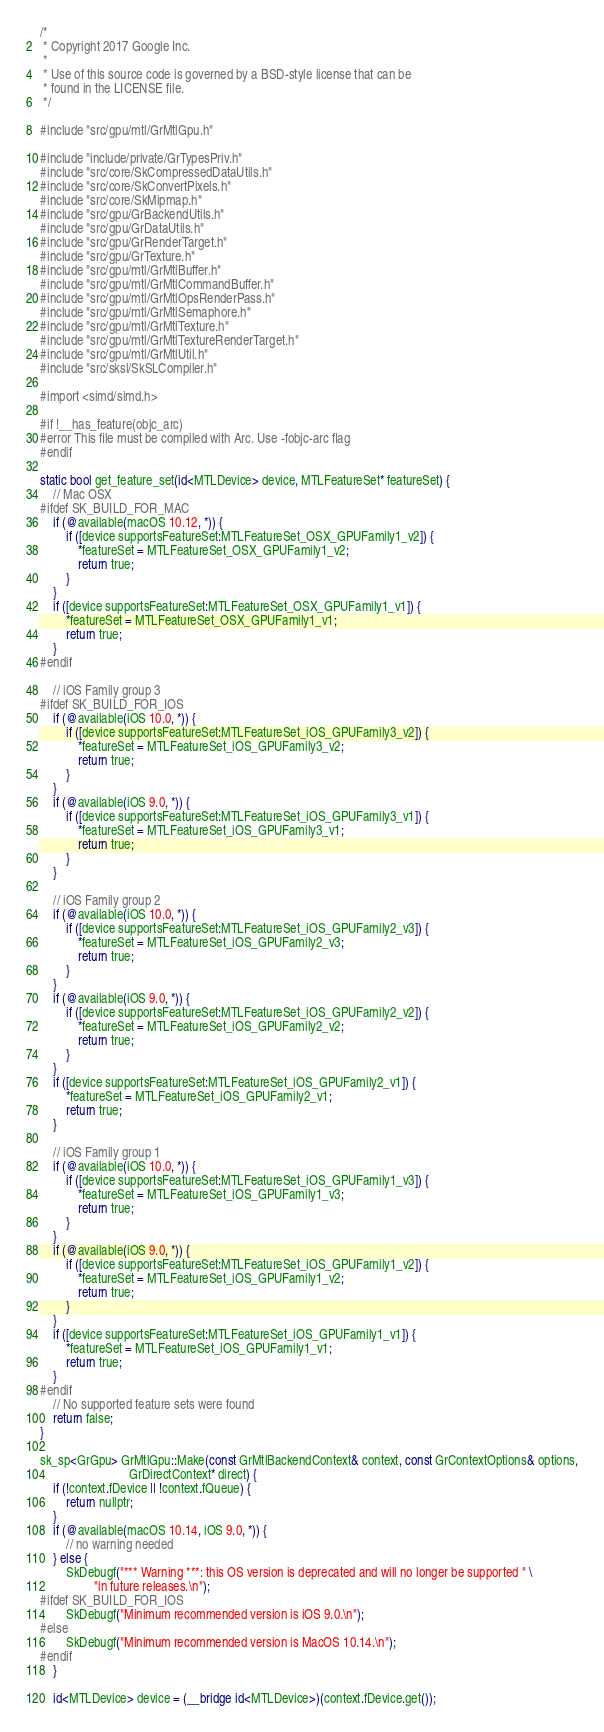<code> <loc_0><loc_0><loc_500><loc_500><_ObjectiveC_>/*
 * Copyright 2017 Google Inc.
 *
 * Use of this source code is governed by a BSD-style license that can be
 * found in the LICENSE file.
 */

#include "src/gpu/mtl/GrMtlGpu.h"

#include "include/private/GrTypesPriv.h"
#include "src/core/SkCompressedDataUtils.h"
#include "src/core/SkConvertPixels.h"
#include "src/core/SkMipmap.h"
#include "src/gpu/GrBackendUtils.h"
#include "src/gpu/GrDataUtils.h"
#include "src/gpu/GrRenderTarget.h"
#include "src/gpu/GrTexture.h"
#include "src/gpu/mtl/GrMtlBuffer.h"
#include "src/gpu/mtl/GrMtlCommandBuffer.h"
#include "src/gpu/mtl/GrMtlOpsRenderPass.h"
#include "src/gpu/mtl/GrMtlSemaphore.h"
#include "src/gpu/mtl/GrMtlTexture.h"
#include "src/gpu/mtl/GrMtlTextureRenderTarget.h"
#include "src/gpu/mtl/GrMtlUtil.h"
#include "src/sksl/SkSLCompiler.h"

#import <simd/simd.h>

#if !__has_feature(objc_arc)
#error This file must be compiled with Arc. Use -fobjc-arc flag
#endif

static bool get_feature_set(id<MTLDevice> device, MTLFeatureSet* featureSet) {
    // Mac OSX
#ifdef SK_BUILD_FOR_MAC
    if (@available(macOS 10.12, *)) {
        if ([device supportsFeatureSet:MTLFeatureSet_OSX_GPUFamily1_v2]) {
            *featureSet = MTLFeatureSet_OSX_GPUFamily1_v2;
            return true;
        }
    }
    if ([device supportsFeatureSet:MTLFeatureSet_OSX_GPUFamily1_v1]) {
        *featureSet = MTLFeatureSet_OSX_GPUFamily1_v1;
        return true;
    }
#endif

    // iOS Family group 3
#ifdef SK_BUILD_FOR_IOS
    if (@available(iOS 10.0, *)) {
        if ([device supportsFeatureSet:MTLFeatureSet_iOS_GPUFamily3_v2]) {
            *featureSet = MTLFeatureSet_iOS_GPUFamily3_v2;
            return true;
        }
    }
    if (@available(iOS 9.0, *)) {
        if ([device supportsFeatureSet:MTLFeatureSet_iOS_GPUFamily3_v1]) {
            *featureSet = MTLFeatureSet_iOS_GPUFamily3_v1;
            return true;
        }
    }

    // iOS Family group 2
    if (@available(iOS 10.0, *)) {
        if ([device supportsFeatureSet:MTLFeatureSet_iOS_GPUFamily2_v3]) {
            *featureSet = MTLFeatureSet_iOS_GPUFamily2_v3;
            return true;
        }
    }
    if (@available(iOS 9.0, *)) {
        if ([device supportsFeatureSet:MTLFeatureSet_iOS_GPUFamily2_v2]) {
            *featureSet = MTLFeatureSet_iOS_GPUFamily2_v2;
            return true;
        }
    }
    if ([device supportsFeatureSet:MTLFeatureSet_iOS_GPUFamily2_v1]) {
        *featureSet = MTLFeatureSet_iOS_GPUFamily2_v1;
        return true;
    }

    // iOS Family group 1
    if (@available(iOS 10.0, *)) {
        if ([device supportsFeatureSet:MTLFeatureSet_iOS_GPUFamily1_v3]) {
            *featureSet = MTLFeatureSet_iOS_GPUFamily1_v3;
            return true;
        }
    }
    if (@available(iOS 9.0, *)) {
        if ([device supportsFeatureSet:MTLFeatureSet_iOS_GPUFamily1_v2]) {
            *featureSet = MTLFeatureSet_iOS_GPUFamily1_v2;
            return true;
        }
    }
    if ([device supportsFeatureSet:MTLFeatureSet_iOS_GPUFamily1_v1]) {
        *featureSet = MTLFeatureSet_iOS_GPUFamily1_v1;
        return true;
    }
#endif
    // No supported feature sets were found
    return false;
}

sk_sp<GrGpu> GrMtlGpu::Make(const GrMtlBackendContext& context, const GrContextOptions& options,
                            GrDirectContext* direct) {
    if (!context.fDevice || !context.fQueue) {
        return nullptr;
    }
    if (@available(macOS 10.14, iOS 9.0, *)) {
        // no warning needed
    } else {
        SkDebugf("*** Warning ***: this OS version is deprecated and will no longer be supported " \
                 "in future releases.\n");
#ifdef SK_BUILD_FOR_IOS
        SkDebugf("Minimum recommended version is iOS 9.0.\n");
#else
        SkDebugf("Minimum recommended version is MacOS 10.14.\n");
#endif
    }

    id<MTLDevice> device = (__bridge id<MTLDevice>)(context.fDevice.get());</code> 